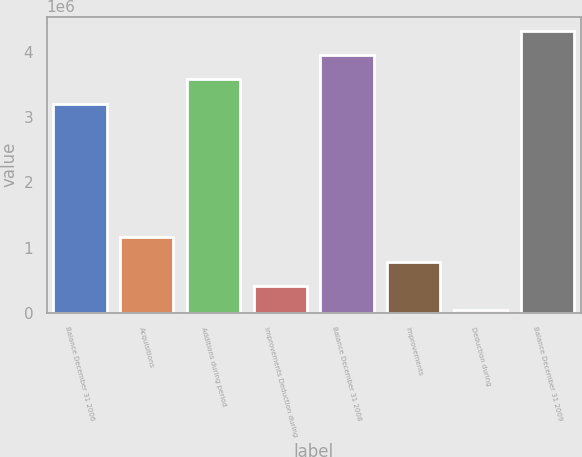Convert chart to OTSL. <chart><loc_0><loc_0><loc_500><loc_500><bar_chart><fcel>Balance December 31 2006<fcel>Acquisitions<fcel>Additions during period<fcel>Improvements Deduction during<fcel>Balance December 31 2008<fcel>Improvements<fcel>Deduction during<fcel>Balance December 31 2009<nl><fcel>3.20426e+06<fcel>1.15734e+06<fcel>3.57596e+06<fcel>413939<fcel>3.94766e+06<fcel>785639<fcel>42240<fcel>4.31936e+06<nl></chart> 